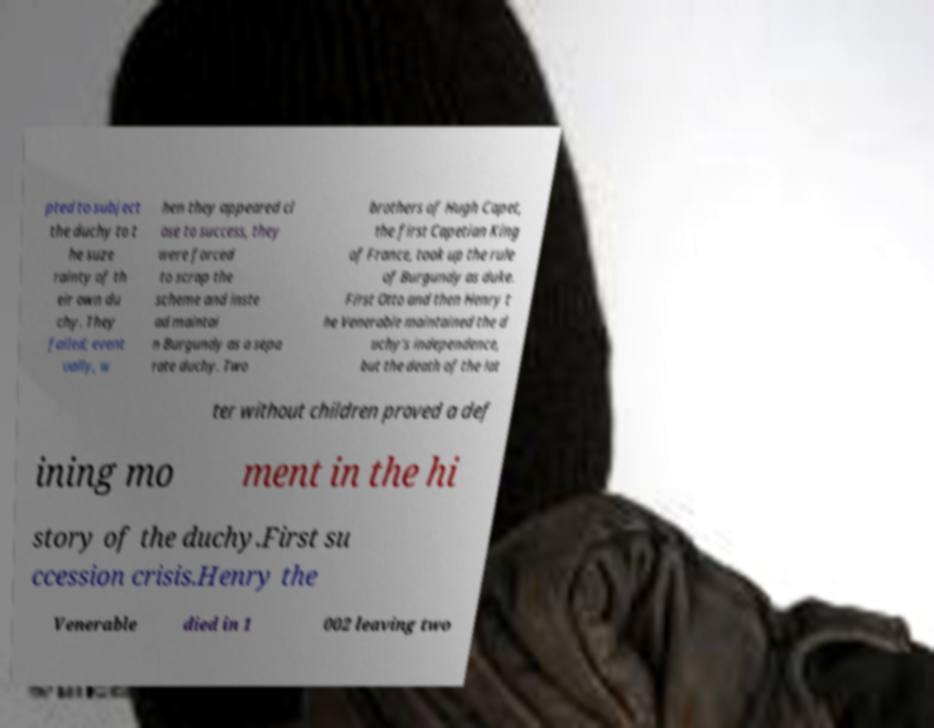There's text embedded in this image that I need extracted. Can you transcribe it verbatim? pted to subject the duchy to t he suze rainty of th eir own du chy. They failed; event ually, w hen they appeared cl ose to success, they were forced to scrap the scheme and inste ad maintai n Burgundy as a sepa rate duchy. Two brothers of Hugh Capet, the first Capetian King of France, took up the rule of Burgundy as duke. First Otto and then Henry t he Venerable maintained the d uchy's independence, but the death of the lat ter without children proved a def ining mo ment in the hi story of the duchy.First su ccession crisis.Henry the Venerable died in 1 002 leaving two 